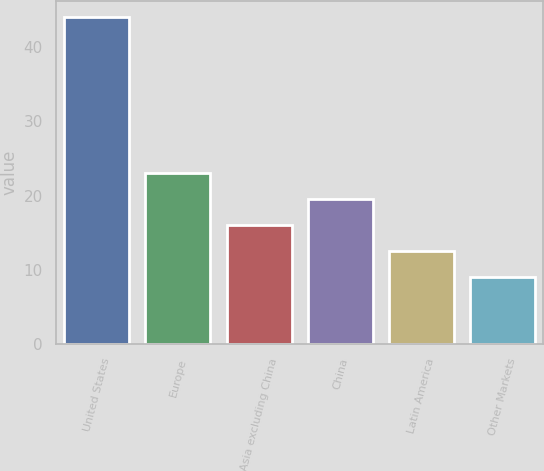Convert chart to OTSL. <chart><loc_0><loc_0><loc_500><loc_500><bar_chart><fcel>United States<fcel>Europe<fcel>Asia excluding China<fcel>China<fcel>Latin America<fcel>Other Markets<nl><fcel>44<fcel>23<fcel>16<fcel>19.5<fcel>12.5<fcel>9<nl></chart> 